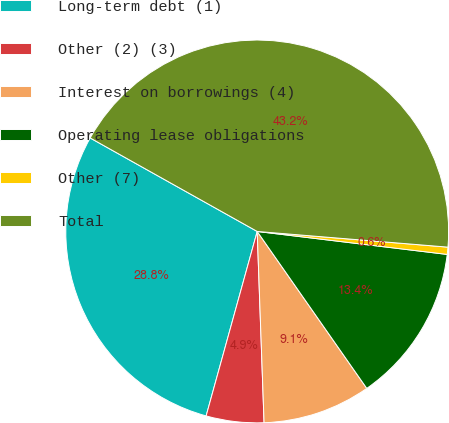Convert chart. <chart><loc_0><loc_0><loc_500><loc_500><pie_chart><fcel>Long-term debt (1)<fcel>Other (2) (3)<fcel>Interest on borrowings (4)<fcel>Operating lease obligations<fcel>Other (7)<fcel>Total<nl><fcel>28.82%<fcel>4.87%<fcel>9.13%<fcel>13.38%<fcel>0.61%<fcel>43.18%<nl></chart> 